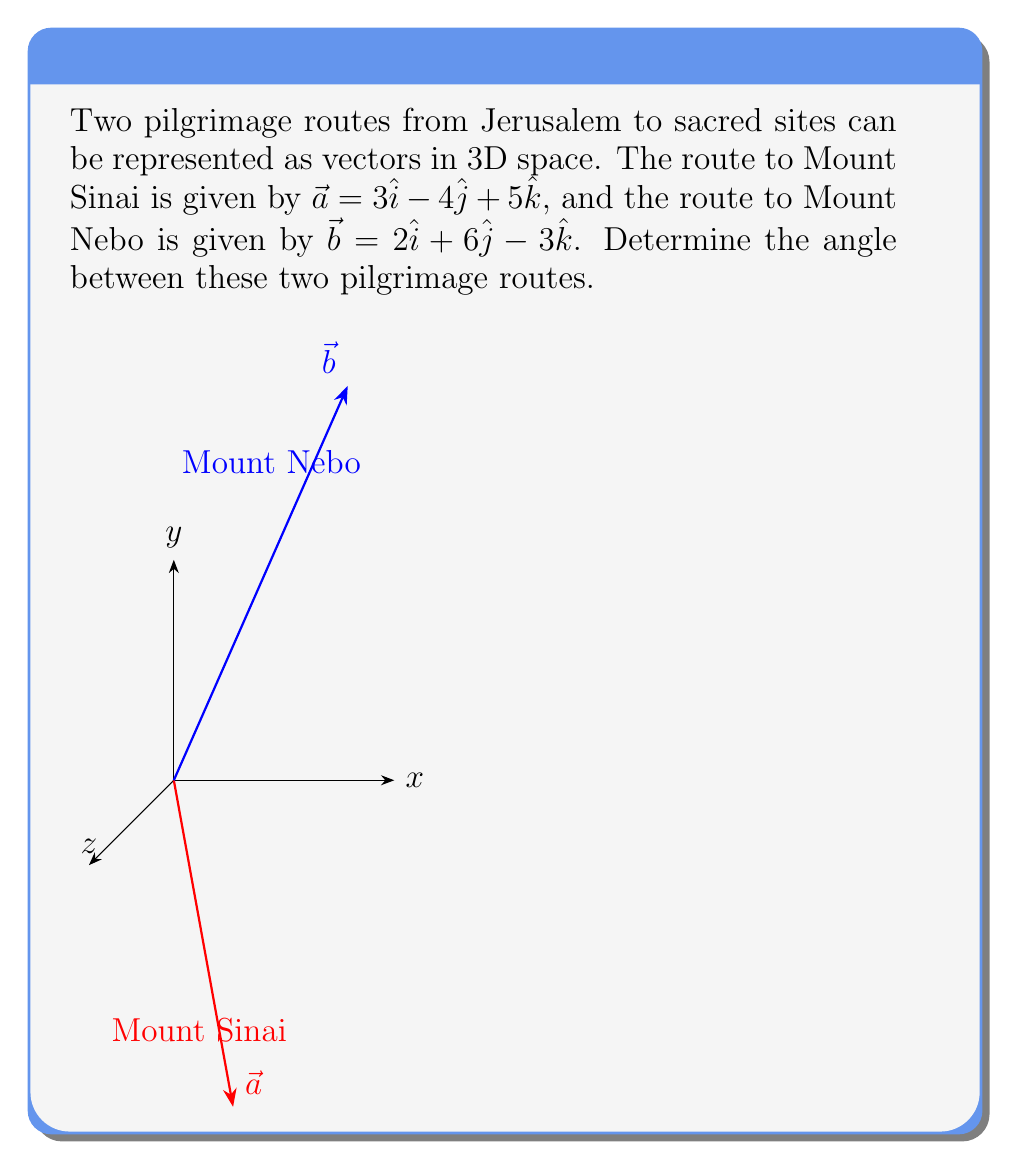What is the answer to this math problem? To find the angle between two vectors using the dot product, we'll follow these steps:

1) The formula for the angle $\theta$ between two vectors $\vec{a}$ and $\vec{b}$ is:

   $$\cos \theta = \frac{\vec{a} \cdot \vec{b}}{|\vec{a}||\vec{b}|}$$

2) Calculate the dot product $\vec{a} \cdot \vec{b}$:
   $$\vec{a} \cdot \vec{b} = (3)(2) + (-4)(6) + (5)(-3) = 6 - 24 - 15 = -33$$

3) Calculate the magnitudes of $\vec{a}$ and $\vec{b}$:
   $$|\vec{a}| = \sqrt{3^2 + (-4)^2 + 5^2} = \sqrt{9 + 16 + 25} = \sqrt{50}$$
   $$|\vec{b}| = \sqrt{2^2 + 6^2 + (-3)^2} = \sqrt{4 + 36 + 9} = \sqrt{49} = 7$$

4) Substitute these values into the formula:
   $$\cos \theta = \frac{-33}{\sqrt{50} \cdot 7}$$

5) Simplify:
   $$\cos \theta = \frac{-33}{7\sqrt{50}} = -\frac{33}{7\sqrt{50}}$$

6) To find $\theta$, take the inverse cosine (arccos) of both sides:
   $$\theta = \arccos(-\frac{33}{7\sqrt{50}})$$

7) Calculate this value:
   $$\theta \approx 2.214 \text{ radians} \approx 126.9°$$
Answer: $\arccos(-\frac{33}{7\sqrt{50}}) \approx 126.9°$ 